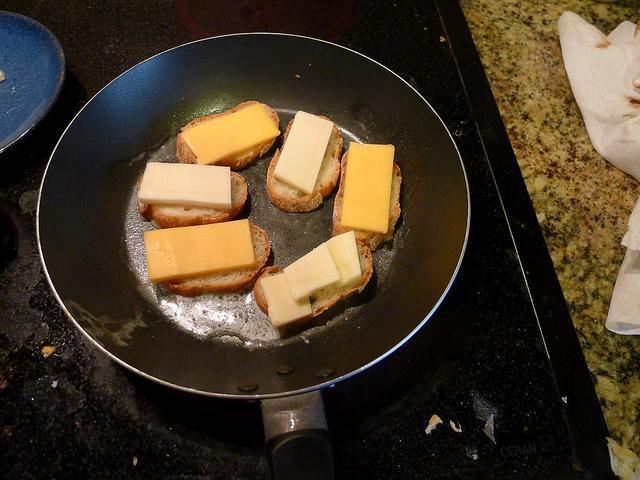How many pieces of bread are there?
Give a very brief answer. 6. How many sandwiches are in the photo?
Give a very brief answer. 5. 